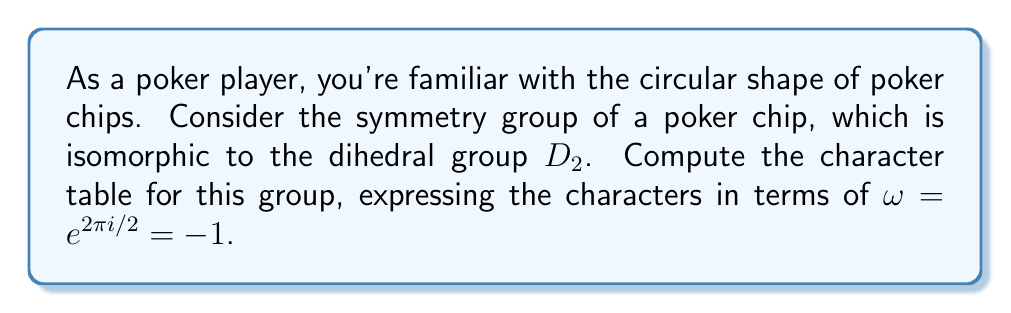Give your solution to this math problem. Let's approach this step-by-step:

1) The dihedral group $D_2$ has 4 elements: 
   - $e$ (identity)
   - $r$ (rotation by 180°)
   - $s$ (reflection across one axis)
   - $rs$ (reflection across the other axis)

2) $D_2$ has 4 conjugacy classes, each containing one element: $\{e\}$, $\{r\}$, $\{s\}$, $\{rs\}$

3) Therefore, $D_2$ has 4 irreducible representations, all of dimension 1.

4) Let's call these representations $\chi_1$, $\chi_2$, $\chi_3$, and $\chi_4$.

5) $\chi_1$ is always the trivial representation, where all elements map to 1.

6) For $\chi_2$, we can define:
   $\chi_2(e) = 1$, $\chi_2(r) = 1$, $\chi_2(s) = -1$, $\chi_2(rs) = -1$

7) For $\chi_3$, we can define:
   $\chi_3(e) = 1$, $\chi_3(r) = -1$, $\chi_3(s) = 1$, $\chi_3(rs) = -1$

8) For $\chi_4$, we can define:
   $\chi_4(e) = 1$, $\chi_4(r) = -1$, $\chi_4(s) = -1$, $\chi_4(rs) = 1$

9) Now we can construct the character table:

   $$
   \begin{array}{c|cccc}
      D_2 & e & r & s & rs \\
      \hline
      \chi_1 & 1 & 1 & 1 & 1 \\
      \chi_2 & 1 & 1 & -1 & -1 \\
      \chi_3 & 1 & -1 & 1 & -1 \\
      \chi_4 & 1 & -1 & -1 & 1
   \end{array}
   $$

10) Note that $\omega = -1$, so we can express -1 as $\omega$ in our final table.
Answer: $$
\begin{array}{c|cccc}
   D_2 & e & r & s & rs \\
   \hline
   \chi_1 & 1 & 1 & 1 & 1 \\
   \chi_2 & 1 & 1 & \omega & \omega \\
   \chi_3 & 1 & \omega & 1 & \omega \\
   \chi_4 & 1 & \omega & \omega & 1
\end{array}
$$ 